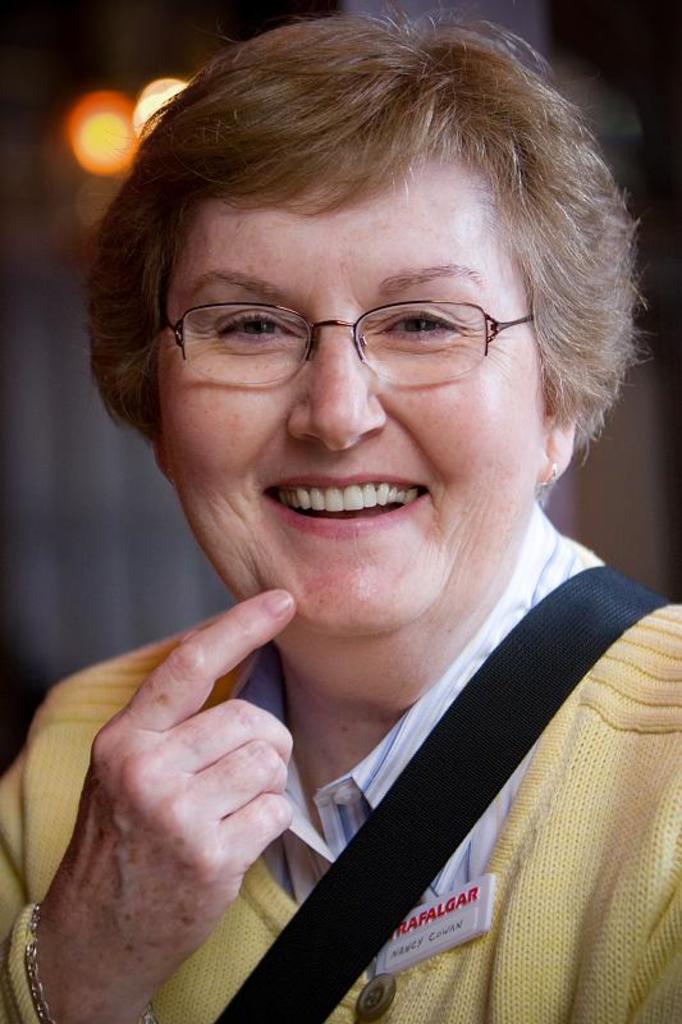Describe this image in one or two sentences. In this image we can see a person. In the background of the image there is a blur background. 